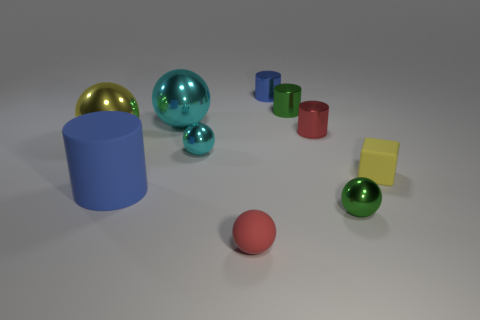Subtract all yellow blocks. How many cyan spheres are left? 2 Subtract all small green metallic spheres. How many spheres are left? 4 Subtract 1 cylinders. How many cylinders are left? 3 Subtract all red spheres. How many spheres are left? 4 Subtract all tiny shiny things. Subtract all big cyan metal objects. How many objects are left? 4 Add 1 tiny metallic balls. How many tiny metallic balls are left? 3 Add 5 yellow metal balls. How many yellow metal balls exist? 6 Subtract 0 purple cubes. How many objects are left? 10 Subtract all cylinders. How many objects are left? 6 Subtract all blue spheres. Subtract all gray cubes. How many spheres are left? 5 